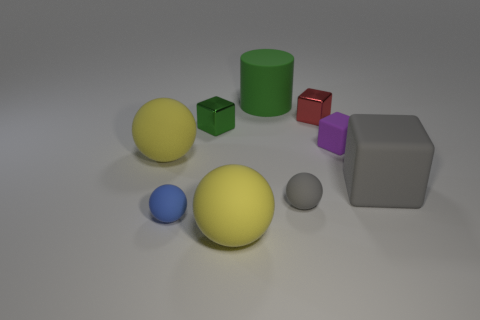There is a green thing to the left of the green matte object; what is its material?
Ensure brevity in your answer.  Metal. There is a gray block that is the same material as the large green thing; what size is it?
Ensure brevity in your answer.  Large. Are there any metallic things on the left side of the small red thing?
Your response must be concise. Yes. What is the size of the gray thing that is the same shape as the tiny purple thing?
Your answer should be compact. Large. There is a large cube; does it have the same color as the small matte ball on the right side of the tiny green thing?
Your response must be concise. Yes. Are there fewer big gray rubber things than big matte balls?
Offer a terse response. Yes. What number of other objects are there of the same color as the large matte cylinder?
Ensure brevity in your answer.  1. How many tiny gray metallic objects are there?
Your answer should be compact. 0. Is the number of big cylinders in front of the purple rubber object less than the number of large rubber objects?
Your answer should be compact. Yes. Do the large yellow ball to the left of the green shiny block and the red object have the same material?
Your answer should be very brief. No. 